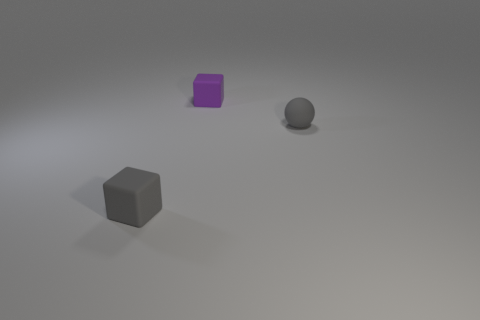Subtract 1 spheres. How many spheres are left? 0 Subtract all gray blocks. How many blocks are left? 1 Subtract all cubes. How many objects are left? 1 Subtract all gray cubes. Subtract all purple spheres. How many cubes are left? 1 Subtract all gray cylinders. How many purple spheres are left? 0 Subtract all large gray rubber spheres. Subtract all small gray things. How many objects are left? 1 Add 1 rubber spheres. How many rubber spheres are left? 2 Add 1 gray matte objects. How many gray matte objects exist? 3 Add 2 large gray shiny cylinders. How many objects exist? 5 Subtract 0 gray cylinders. How many objects are left? 3 